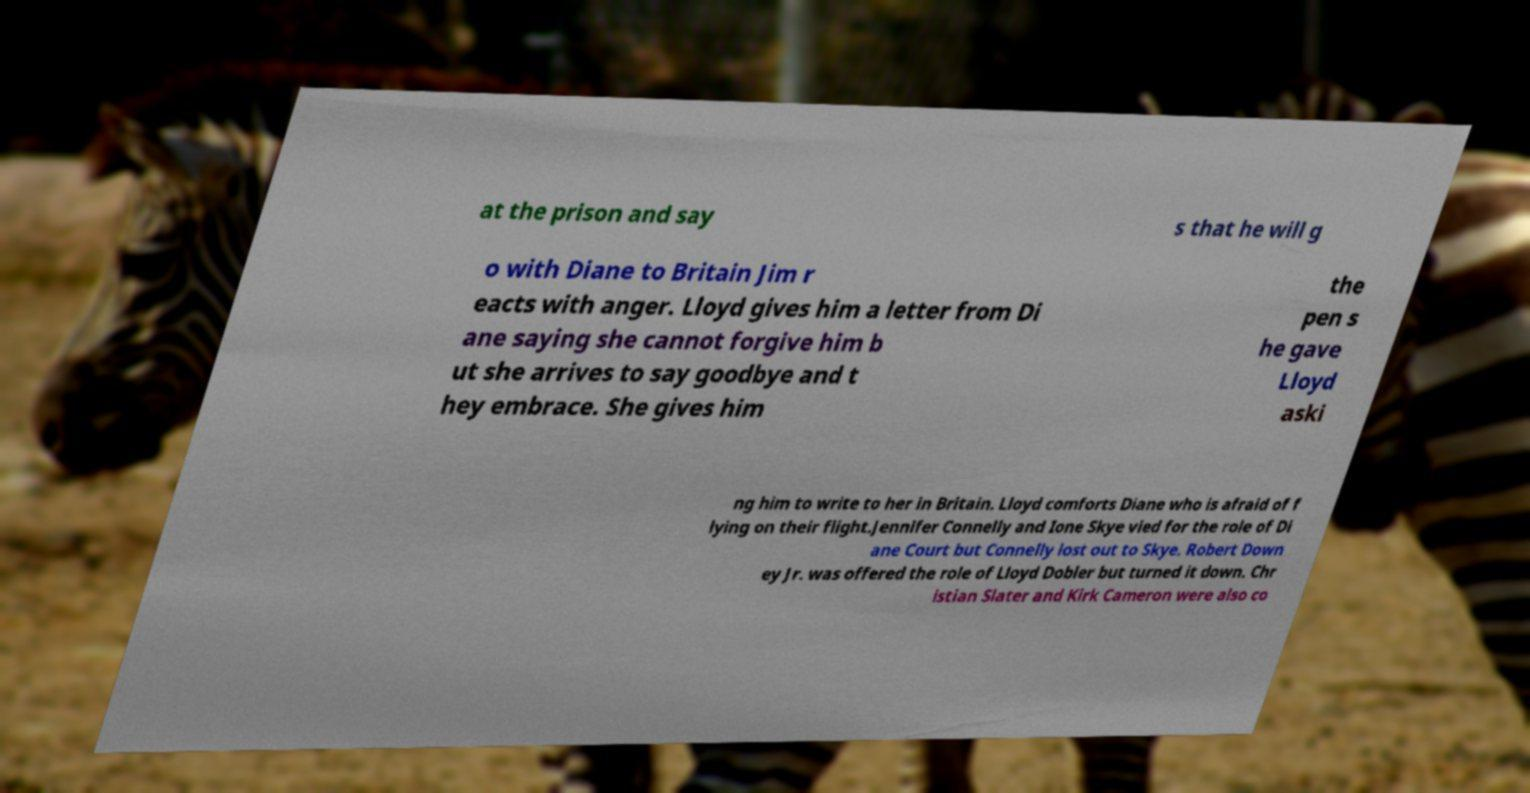Could you extract and type out the text from this image? at the prison and say s that he will g o with Diane to Britain Jim r eacts with anger. Lloyd gives him a letter from Di ane saying she cannot forgive him b ut she arrives to say goodbye and t hey embrace. She gives him the pen s he gave Lloyd aski ng him to write to her in Britain. Lloyd comforts Diane who is afraid of f lying on their flight.Jennifer Connelly and Ione Skye vied for the role of Di ane Court but Connelly lost out to Skye. Robert Down ey Jr. was offered the role of Lloyd Dobler but turned it down. Chr istian Slater and Kirk Cameron were also co 